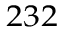Convert formula to latex. <formula><loc_0><loc_0><loc_500><loc_500>^ { 2 3 2 }</formula> 